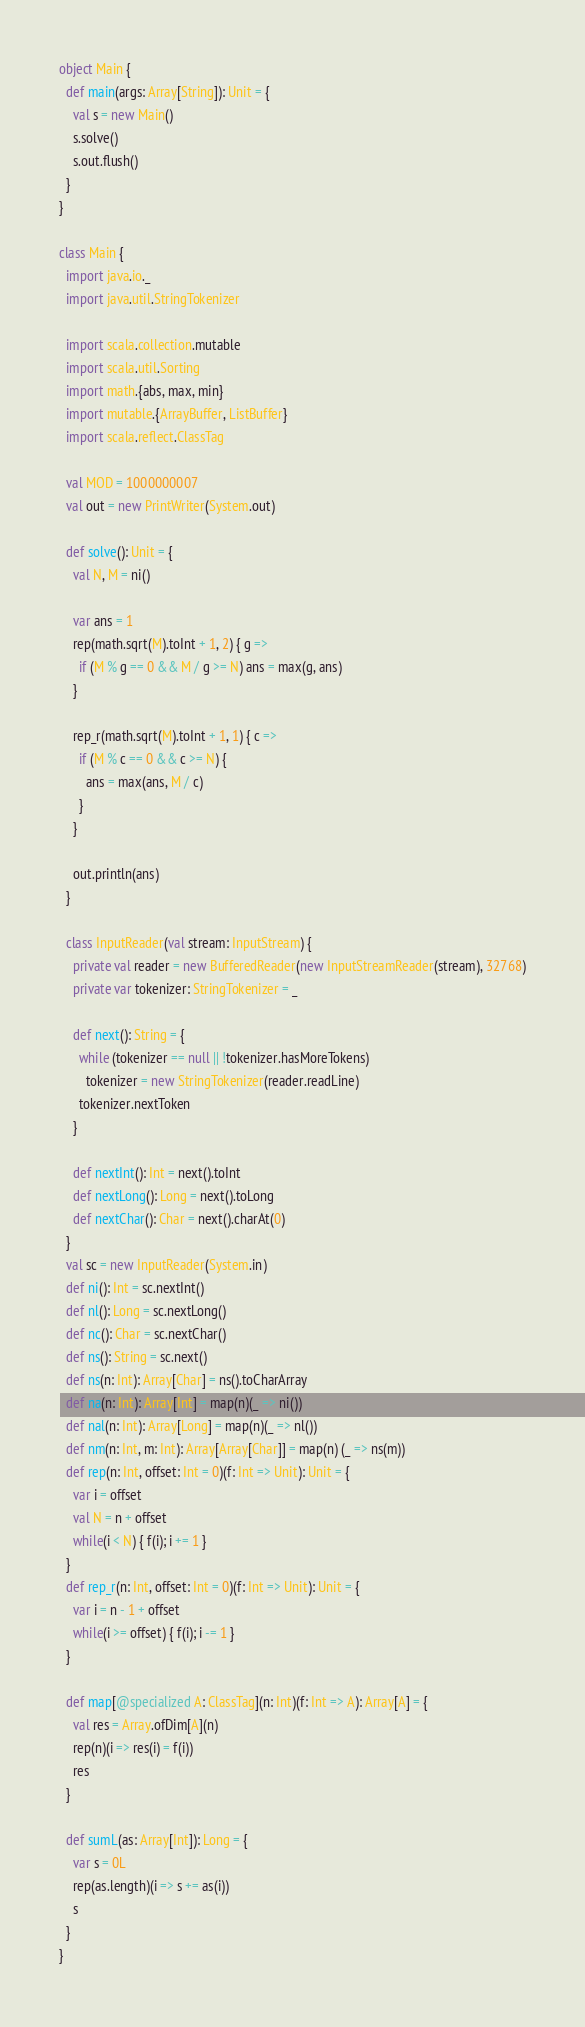Convert code to text. <code><loc_0><loc_0><loc_500><loc_500><_Scala_>object Main {
  def main(args: Array[String]): Unit = {
    val s = new Main()
    s.solve()
    s.out.flush()
  }
}

class Main {
  import java.io._
  import java.util.StringTokenizer

  import scala.collection.mutable
  import scala.util.Sorting
  import math.{abs, max, min}
  import mutable.{ArrayBuffer, ListBuffer}
  import scala.reflect.ClassTag

  val MOD = 1000000007
  val out = new PrintWriter(System.out)

  def solve(): Unit = {
    val N, M = ni()

    var ans = 1
    rep(math.sqrt(M).toInt + 1, 2) { g =>
      if (M % g == 0 && M / g >= N) ans = max(g, ans)
    }

    rep_r(math.sqrt(M).toInt + 1, 1) { c =>
      if (M % c == 0 && c >= N) {
        ans = max(ans, M / c)
      }
    }

    out.println(ans)
  }

  class InputReader(val stream: InputStream) {
    private val reader = new BufferedReader(new InputStreamReader(stream), 32768)
    private var tokenizer: StringTokenizer = _

    def next(): String = {
      while (tokenizer == null || !tokenizer.hasMoreTokens)
        tokenizer = new StringTokenizer(reader.readLine)
      tokenizer.nextToken
    }

    def nextInt(): Int = next().toInt
    def nextLong(): Long = next().toLong
    def nextChar(): Char = next().charAt(0)
  }
  val sc = new InputReader(System.in)
  def ni(): Int = sc.nextInt()
  def nl(): Long = sc.nextLong()
  def nc(): Char = sc.nextChar()
  def ns(): String = sc.next()
  def ns(n: Int): Array[Char] = ns().toCharArray
  def na(n: Int): Array[Int] = map(n)(_ => ni())
  def nal(n: Int): Array[Long] = map(n)(_ => nl())
  def nm(n: Int, m: Int): Array[Array[Char]] = map(n) (_ => ns(m))
  def rep(n: Int, offset: Int = 0)(f: Int => Unit): Unit = {
    var i = offset
    val N = n + offset
    while(i < N) { f(i); i += 1 }
  }
  def rep_r(n: Int, offset: Int = 0)(f: Int => Unit): Unit = {
    var i = n - 1 + offset
    while(i >= offset) { f(i); i -= 1 }
  }

  def map[@specialized A: ClassTag](n: Int)(f: Int => A): Array[A] = {
    val res = Array.ofDim[A](n)
    rep(n)(i => res(i) = f(i))
    res
  }

  def sumL(as: Array[Int]): Long = {
    var s = 0L
    rep(as.length)(i => s += as(i))
    s
  }
}</code> 